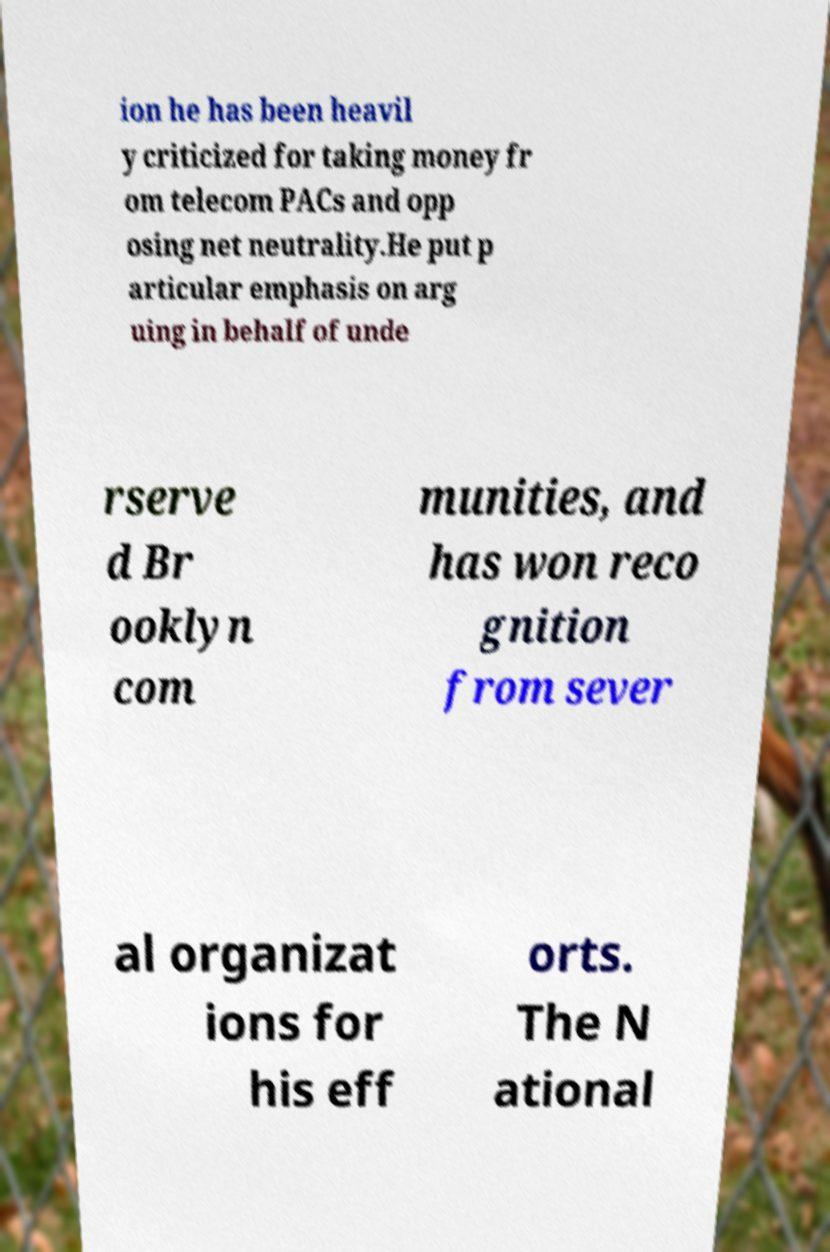Can you accurately transcribe the text from the provided image for me? ion he has been heavil y criticized for taking money fr om telecom PACs and opp osing net neutrality.He put p articular emphasis on arg uing in behalf of unde rserve d Br ooklyn com munities, and has won reco gnition from sever al organizat ions for his eff orts. The N ational 